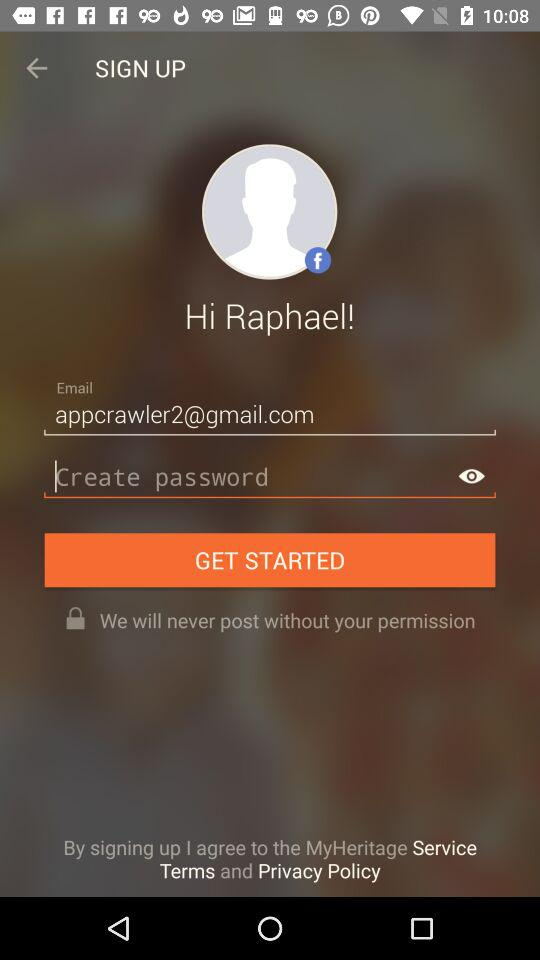What is the user name? The user name is "Raphael". 